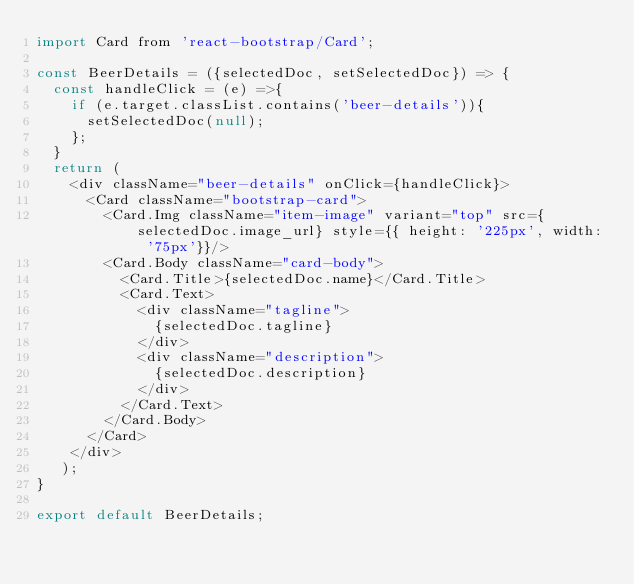<code> <loc_0><loc_0><loc_500><loc_500><_JavaScript_>import Card from 'react-bootstrap/Card';

const BeerDetails = ({selectedDoc, setSelectedDoc}) => {
  const handleClick = (e) =>{
    if (e.target.classList.contains('beer-details')){
      setSelectedDoc(null);
    };
  }
  return ( 
    <div className="beer-details" onClick={handleClick}>
      <Card className="bootstrap-card">
        <Card.Img className="item-image" variant="top" src={selectedDoc.image_url} style={{ height: '225px', width: '75px'}}/>
        <Card.Body className="card-body">
          <Card.Title>{selectedDoc.name}</Card.Title>
          <Card.Text>
            <div className="tagline">
              {selectedDoc.tagline}
            </div>
            <div className="description">
              {selectedDoc.description}
            </div>
          </Card.Text>
        </Card.Body>
      </Card>
    </div>
   );
}
 
export default BeerDetails;</code> 